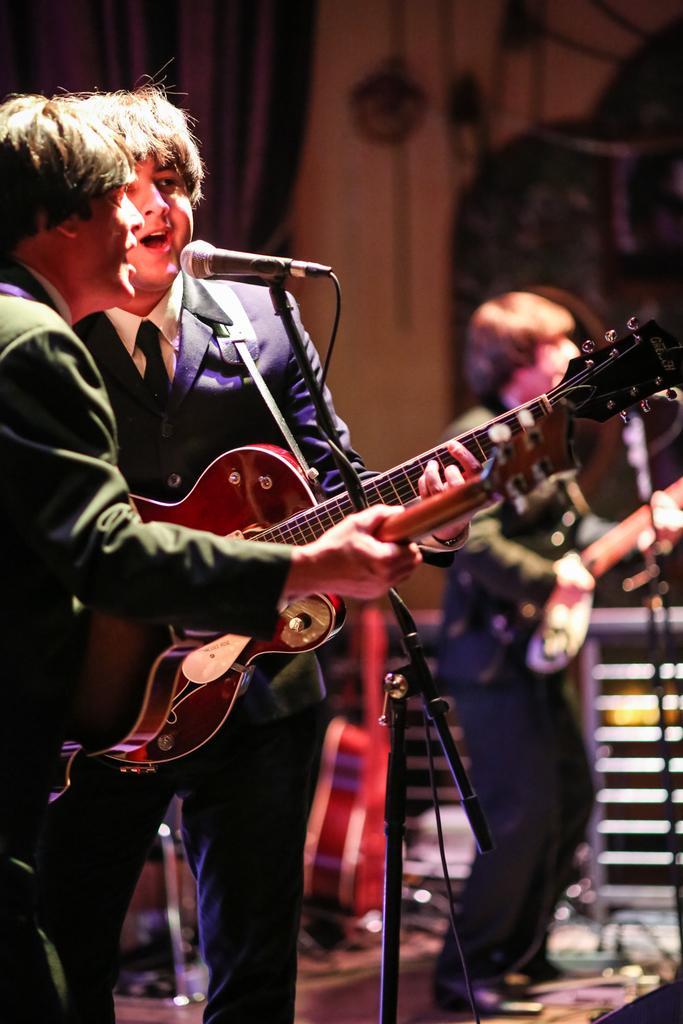In one or two sentences, can you explain what this image depicts? In this image, there are some people standing and holding some music instruments they are singing in the microphone which is in black color, in the right side there is a person standing and holding a music instrument, in the background there is a white color wall and there is a blue color curtain. 